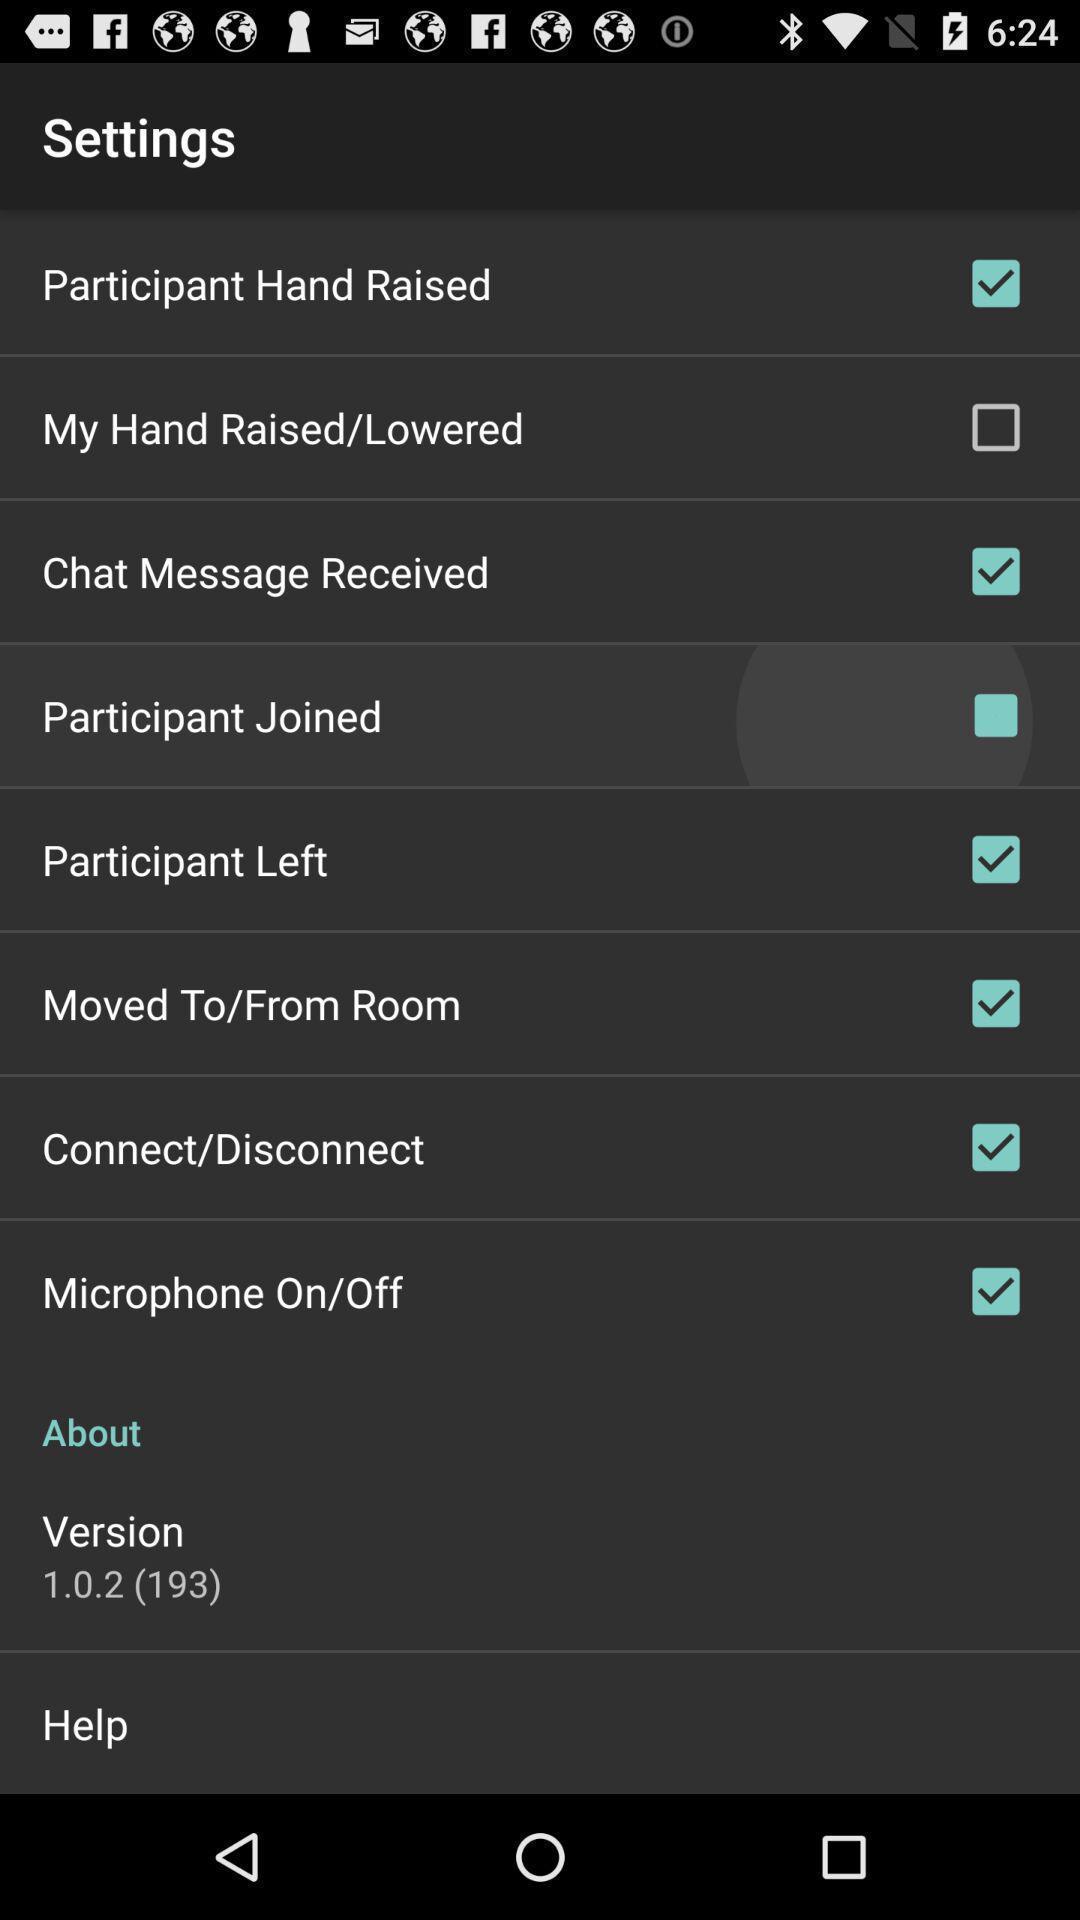Give me a narrative description of this picture. Settings page with different options in the social app. 